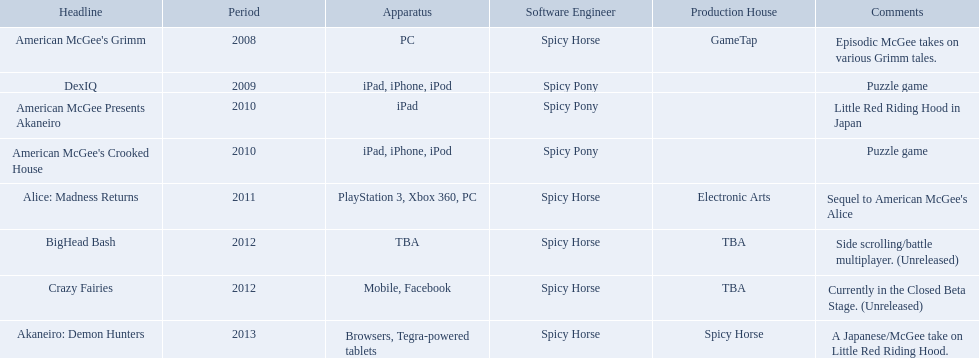Which spicy horse titles are shown? American McGee's Grimm, DexIQ, American McGee Presents Akaneiro, American McGee's Crooked House, Alice: Madness Returns, BigHead Bash, Crazy Fairies, Akaneiro: Demon Hunters. Of those, which are for the ipad? DexIQ, American McGee Presents Akaneiro, American McGee's Crooked House. Which of those are not for the iphone or ipod? American McGee Presents Akaneiro. What are all the titles of games published? American McGee's Grimm, DexIQ, American McGee Presents Akaneiro, American McGee's Crooked House, Alice: Madness Returns, BigHead Bash, Crazy Fairies, Akaneiro: Demon Hunters. What are all the names of the publishers? GameTap, , , , Electronic Arts, TBA, TBA, Spicy Horse. What is the published game title that corresponds to electronic arts? Alice: Madness Returns. 